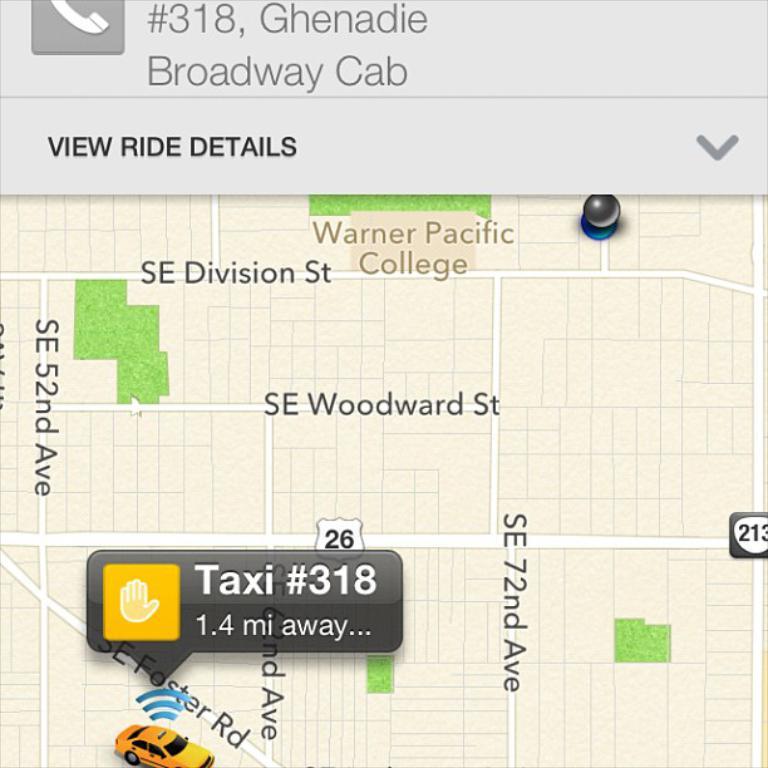Thats an app?
Keep it short and to the point. Yes. What number taxi is on the map?
Make the answer very short. 318. 